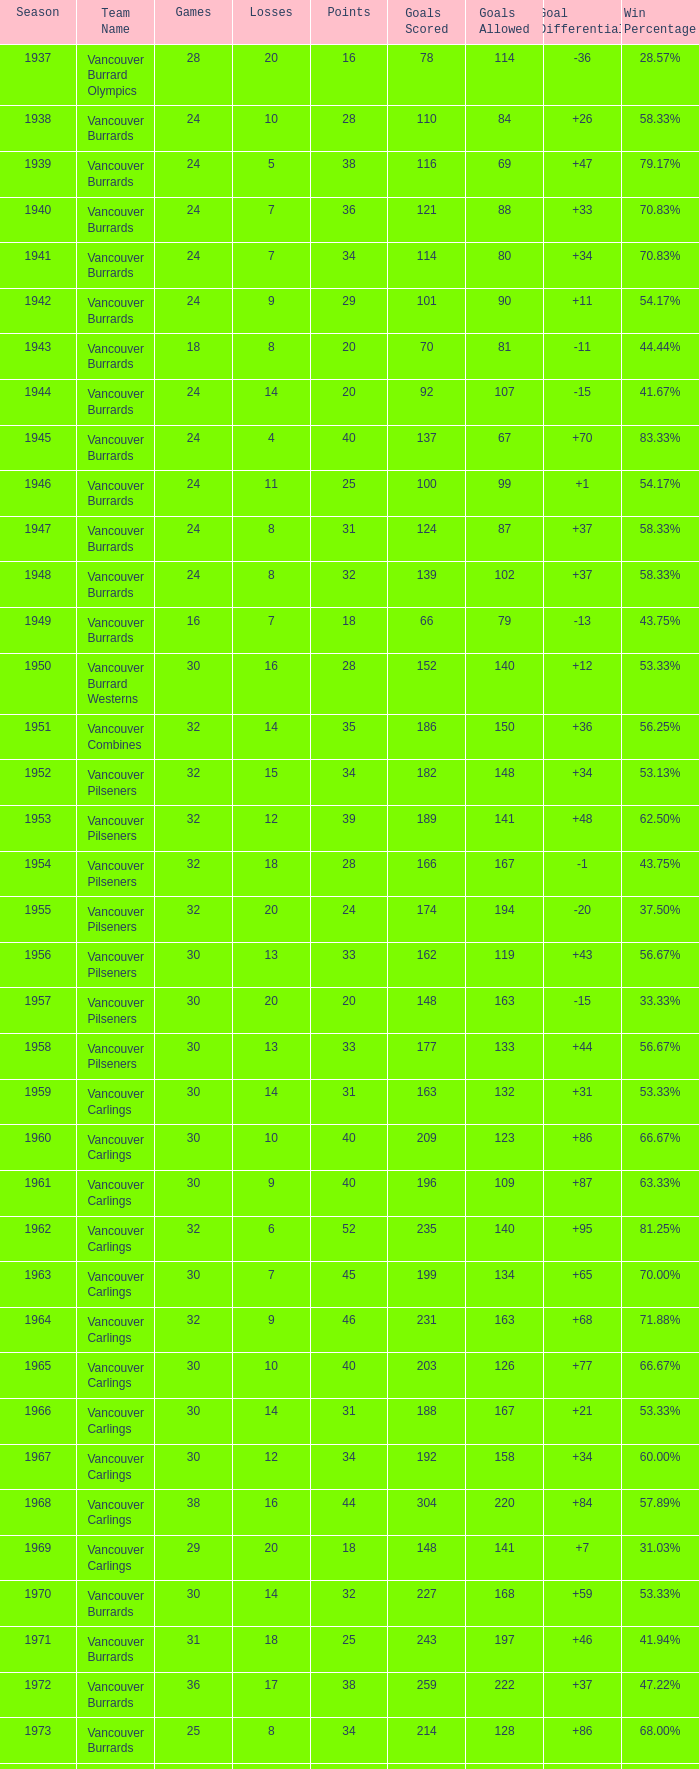What's the total number of games with more than 20 points for the 1976 season? 0.0. 